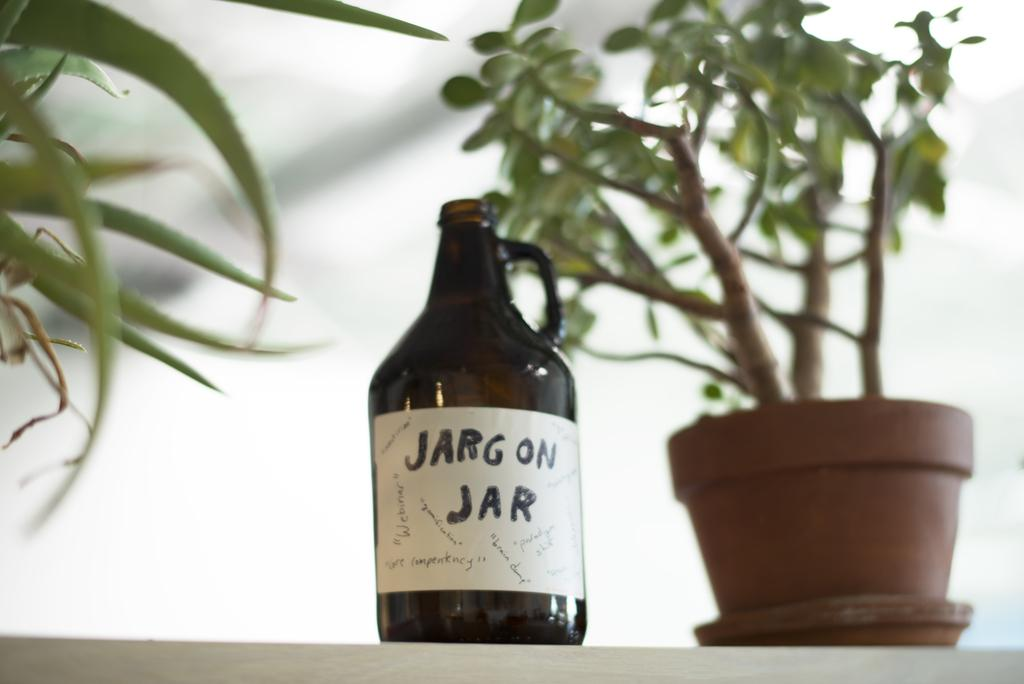What object can be seen in the image? There is a bottle in the image. What is located near the bottle? There is a plant beside the bottle in the image. What type of canvas is used to cover the mailbox in the image? There is no mailbox or canvas present in the image. 